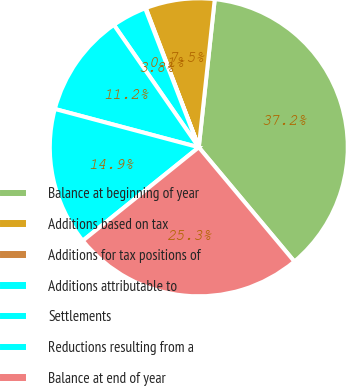Convert chart to OTSL. <chart><loc_0><loc_0><loc_500><loc_500><pie_chart><fcel>Balance at beginning of year<fcel>Additions based on tax<fcel>Additions for tax positions of<fcel>Additions attributable to<fcel>Settlements<fcel>Reductions resulting from a<fcel>Balance at end of year<nl><fcel>37.2%<fcel>7.5%<fcel>0.07%<fcel>3.79%<fcel>11.21%<fcel>14.93%<fcel>25.3%<nl></chart> 